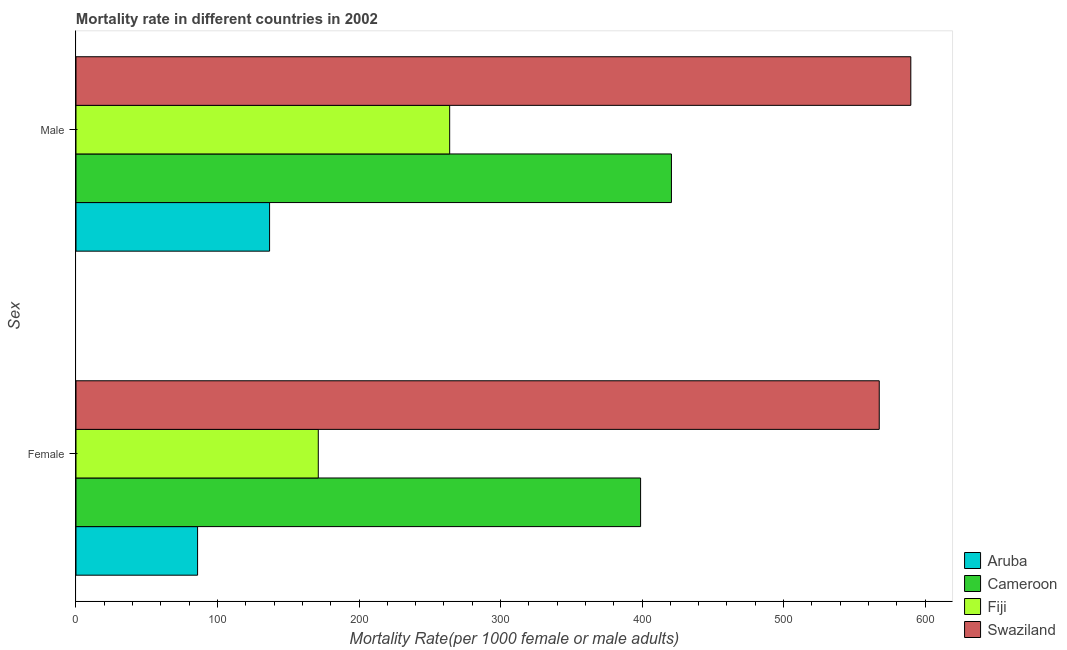How many bars are there on the 2nd tick from the top?
Provide a succinct answer. 4. What is the label of the 2nd group of bars from the top?
Keep it short and to the point. Female. What is the female mortality rate in Fiji?
Your answer should be very brief. 171.21. Across all countries, what is the maximum female mortality rate?
Provide a short and direct response. 567.61. Across all countries, what is the minimum male mortality rate?
Offer a very short reply. 136.79. In which country was the male mortality rate maximum?
Your response must be concise. Swaziland. In which country was the female mortality rate minimum?
Offer a terse response. Aruba. What is the total female mortality rate in the graph?
Offer a very short reply. 1223.7. What is the difference between the female mortality rate in Aruba and that in Fiji?
Ensure brevity in your answer.  -85.29. What is the difference between the female mortality rate in Swaziland and the male mortality rate in Cameroon?
Your answer should be compact. 146.85. What is the average female mortality rate per country?
Ensure brevity in your answer.  305.93. What is the difference between the female mortality rate and male mortality rate in Cameroon?
Ensure brevity in your answer.  -21.8. What is the ratio of the female mortality rate in Swaziland to that in Aruba?
Your answer should be very brief. 6.61. What does the 3rd bar from the top in Male represents?
Provide a succinct answer. Cameroon. What does the 2nd bar from the bottom in Male represents?
Your response must be concise. Cameroon. Are all the bars in the graph horizontal?
Ensure brevity in your answer.  Yes. What is the difference between two consecutive major ticks on the X-axis?
Offer a very short reply. 100. Are the values on the major ticks of X-axis written in scientific E-notation?
Offer a very short reply. No. Where does the legend appear in the graph?
Your answer should be compact. Bottom right. How many legend labels are there?
Provide a short and direct response. 4. What is the title of the graph?
Provide a succinct answer. Mortality rate in different countries in 2002. What is the label or title of the X-axis?
Provide a short and direct response. Mortality Rate(per 1000 female or male adults). What is the label or title of the Y-axis?
Give a very brief answer. Sex. What is the Mortality Rate(per 1000 female or male adults) in Aruba in Female?
Provide a short and direct response. 85.92. What is the Mortality Rate(per 1000 female or male adults) in Cameroon in Female?
Your response must be concise. 398.96. What is the Mortality Rate(per 1000 female or male adults) of Fiji in Female?
Ensure brevity in your answer.  171.21. What is the Mortality Rate(per 1000 female or male adults) of Swaziland in Female?
Your response must be concise. 567.61. What is the Mortality Rate(per 1000 female or male adults) in Aruba in Male?
Your answer should be compact. 136.79. What is the Mortality Rate(per 1000 female or male adults) of Cameroon in Male?
Offer a terse response. 420.76. What is the Mortality Rate(per 1000 female or male adults) of Fiji in Male?
Give a very brief answer. 264.06. What is the Mortality Rate(per 1000 female or male adults) of Swaziland in Male?
Offer a terse response. 589.91. Across all Sex, what is the maximum Mortality Rate(per 1000 female or male adults) of Aruba?
Provide a succinct answer. 136.79. Across all Sex, what is the maximum Mortality Rate(per 1000 female or male adults) of Cameroon?
Your answer should be very brief. 420.76. Across all Sex, what is the maximum Mortality Rate(per 1000 female or male adults) of Fiji?
Offer a terse response. 264.06. Across all Sex, what is the maximum Mortality Rate(per 1000 female or male adults) of Swaziland?
Your answer should be compact. 589.91. Across all Sex, what is the minimum Mortality Rate(per 1000 female or male adults) of Aruba?
Your answer should be very brief. 85.92. Across all Sex, what is the minimum Mortality Rate(per 1000 female or male adults) of Cameroon?
Give a very brief answer. 398.96. Across all Sex, what is the minimum Mortality Rate(per 1000 female or male adults) of Fiji?
Keep it short and to the point. 171.21. Across all Sex, what is the minimum Mortality Rate(per 1000 female or male adults) of Swaziland?
Ensure brevity in your answer.  567.61. What is the total Mortality Rate(per 1000 female or male adults) in Aruba in the graph?
Your response must be concise. 222.71. What is the total Mortality Rate(per 1000 female or male adults) of Cameroon in the graph?
Make the answer very short. 819.72. What is the total Mortality Rate(per 1000 female or male adults) in Fiji in the graph?
Ensure brevity in your answer.  435.27. What is the total Mortality Rate(per 1000 female or male adults) of Swaziland in the graph?
Make the answer very short. 1157.52. What is the difference between the Mortality Rate(per 1000 female or male adults) in Aruba in Female and that in Male?
Your answer should be very brief. -50.87. What is the difference between the Mortality Rate(per 1000 female or male adults) in Cameroon in Female and that in Male?
Keep it short and to the point. -21.8. What is the difference between the Mortality Rate(per 1000 female or male adults) in Fiji in Female and that in Male?
Provide a succinct answer. -92.84. What is the difference between the Mortality Rate(per 1000 female or male adults) of Swaziland in Female and that in Male?
Your answer should be very brief. -22.3. What is the difference between the Mortality Rate(per 1000 female or male adults) of Aruba in Female and the Mortality Rate(per 1000 female or male adults) of Cameroon in Male?
Keep it short and to the point. -334.84. What is the difference between the Mortality Rate(per 1000 female or male adults) of Aruba in Female and the Mortality Rate(per 1000 female or male adults) of Fiji in Male?
Give a very brief answer. -178.14. What is the difference between the Mortality Rate(per 1000 female or male adults) in Aruba in Female and the Mortality Rate(per 1000 female or male adults) in Swaziland in Male?
Keep it short and to the point. -503.99. What is the difference between the Mortality Rate(per 1000 female or male adults) of Cameroon in Female and the Mortality Rate(per 1000 female or male adults) of Fiji in Male?
Your answer should be compact. 134.91. What is the difference between the Mortality Rate(per 1000 female or male adults) in Cameroon in Female and the Mortality Rate(per 1000 female or male adults) in Swaziland in Male?
Offer a terse response. -190.95. What is the difference between the Mortality Rate(per 1000 female or male adults) of Fiji in Female and the Mortality Rate(per 1000 female or male adults) of Swaziland in Male?
Offer a terse response. -418.7. What is the average Mortality Rate(per 1000 female or male adults) in Aruba per Sex?
Ensure brevity in your answer.  111.36. What is the average Mortality Rate(per 1000 female or male adults) in Cameroon per Sex?
Your response must be concise. 409.86. What is the average Mortality Rate(per 1000 female or male adults) of Fiji per Sex?
Provide a succinct answer. 217.63. What is the average Mortality Rate(per 1000 female or male adults) in Swaziland per Sex?
Your answer should be compact. 578.76. What is the difference between the Mortality Rate(per 1000 female or male adults) of Aruba and Mortality Rate(per 1000 female or male adults) of Cameroon in Female?
Your answer should be very brief. -313.04. What is the difference between the Mortality Rate(per 1000 female or male adults) of Aruba and Mortality Rate(per 1000 female or male adults) of Fiji in Female?
Keep it short and to the point. -85.29. What is the difference between the Mortality Rate(per 1000 female or male adults) of Aruba and Mortality Rate(per 1000 female or male adults) of Swaziland in Female?
Make the answer very short. -481.69. What is the difference between the Mortality Rate(per 1000 female or male adults) of Cameroon and Mortality Rate(per 1000 female or male adults) of Fiji in Female?
Make the answer very short. 227.75. What is the difference between the Mortality Rate(per 1000 female or male adults) in Cameroon and Mortality Rate(per 1000 female or male adults) in Swaziland in Female?
Offer a very short reply. -168.65. What is the difference between the Mortality Rate(per 1000 female or male adults) of Fiji and Mortality Rate(per 1000 female or male adults) of Swaziland in Female?
Your response must be concise. -396.4. What is the difference between the Mortality Rate(per 1000 female or male adults) of Aruba and Mortality Rate(per 1000 female or male adults) of Cameroon in Male?
Make the answer very short. -283.97. What is the difference between the Mortality Rate(per 1000 female or male adults) in Aruba and Mortality Rate(per 1000 female or male adults) in Fiji in Male?
Make the answer very short. -127.27. What is the difference between the Mortality Rate(per 1000 female or male adults) in Aruba and Mortality Rate(per 1000 female or male adults) in Swaziland in Male?
Make the answer very short. -453.12. What is the difference between the Mortality Rate(per 1000 female or male adults) of Cameroon and Mortality Rate(per 1000 female or male adults) of Fiji in Male?
Offer a very short reply. 156.7. What is the difference between the Mortality Rate(per 1000 female or male adults) in Cameroon and Mortality Rate(per 1000 female or male adults) in Swaziland in Male?
Offer a terse response. -169.15. What is the difference between the Mortality Rate(per 1000 female or male adults) in Fiji and Mortality Rate(per 1000 female or male adults) in Swaziland in Male?
Your response must be concise. -325.85. What is the ratio of the Mortality Rate(per 1000 female or male adults) in Aruba in Female to that in Male?
Ensure brevity in your answer.  0.63. What is the ratio of the Mortality Rate(per 1000 female or male adults) of Cameroon in Female to that in Male?
Provide a short and direct response. 0.95. What is the ratio of the Mortality Rate(per 1000 female or male adults) in Fiji in Female to that in Male?
Offer a terse response. 0.65. What is the ratio of the Mortality Rate(per 1000 female or male adults) in Swaziland in Female to that in Male?
Your answer should be compact. 0.96. What is the difference between the highest and the second highest Mortality Rate(per 1000 female or male adults) of Aruba?
Ensure brevity in your answer.  50.87. What is the difference between the highest and the second highest Mortality Rate(per 1000 female or male adults) of Cameroon?
Keep it short and to the point. 21.8. What is the difference between the highest and the second highest Mortality Rate(per 1000 female or male adults) of Fiji?
Offer a very short reply. 92.84. What is the difference between the highest and the second highest Mortality Rate(per 1000 female or male adults) in Swaziland?
Ensure brevity in your answer.  22.3. What is the difference between the highest and the lowest Mortality Rate(per 1000 female or male adults) in Aruba?
Your response must be concise. 50.87. What is the difference between the highest and the lowest Mortality Rate(per 1000 female or male adults) of Cameroon?
Give a very brief answer. 21.8. What is the difference between the highest and the lowest Mortality Rate(per 1000 female or male adults) in Fiji?
Ensure brevity in your answer.  92.84. What is the difference between the highest and the lowest Mortality Rate(per 1000 female or male adults) in Swaziland?
Provide a succinct answer. 22.3. 